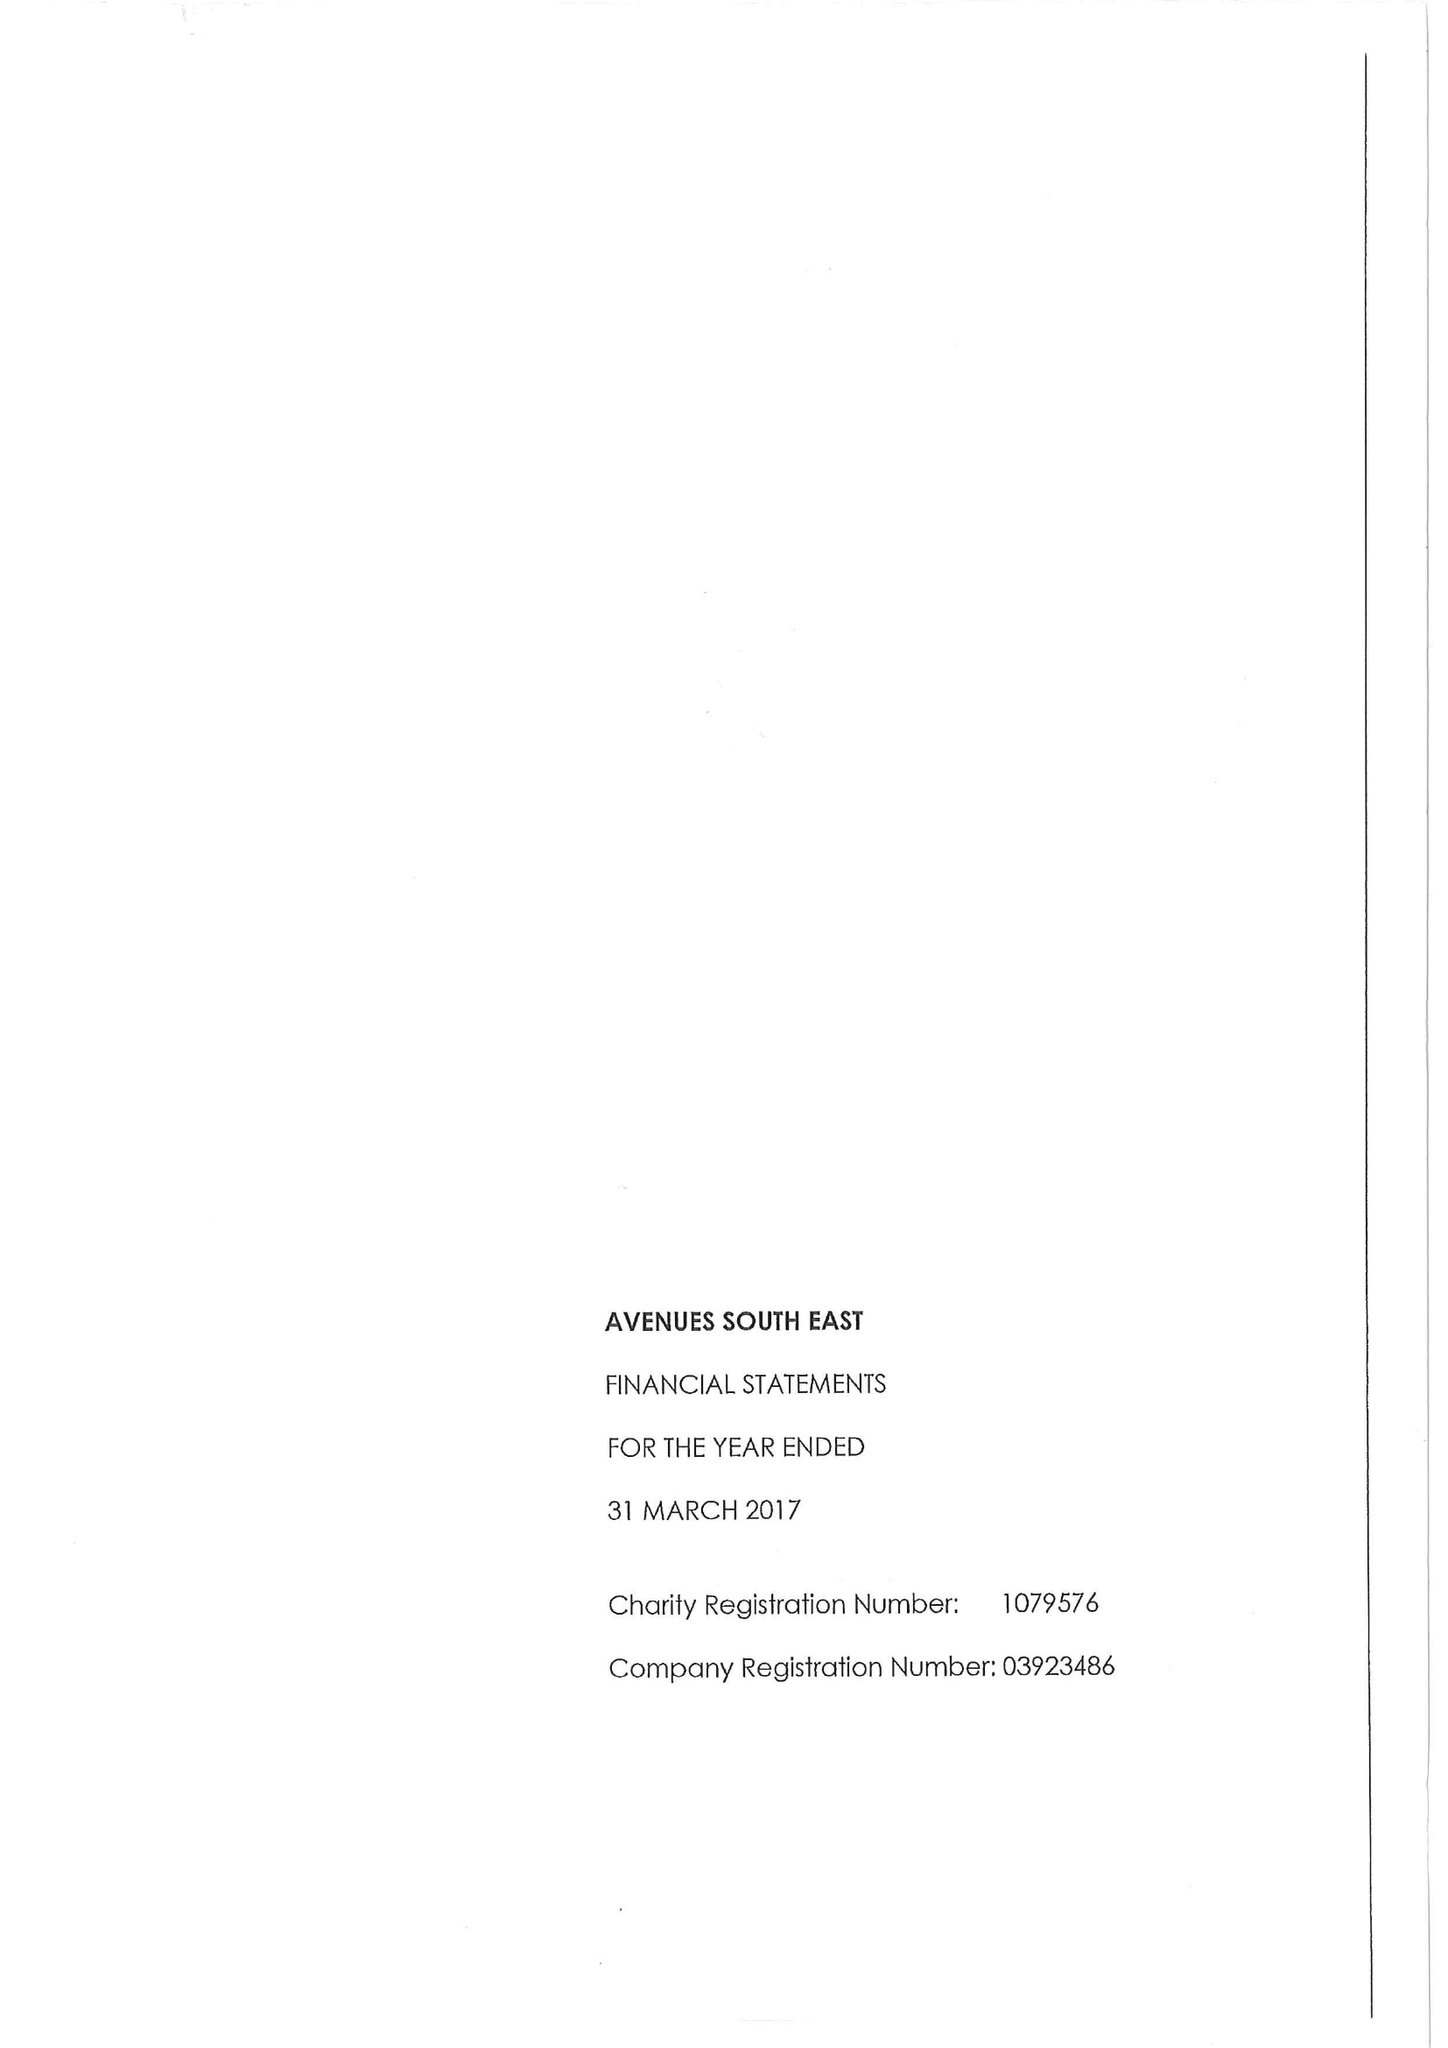What is the value for the spending_annually_in_british_pounds?
Answer the question using a single word or phrase. 15738000.00 